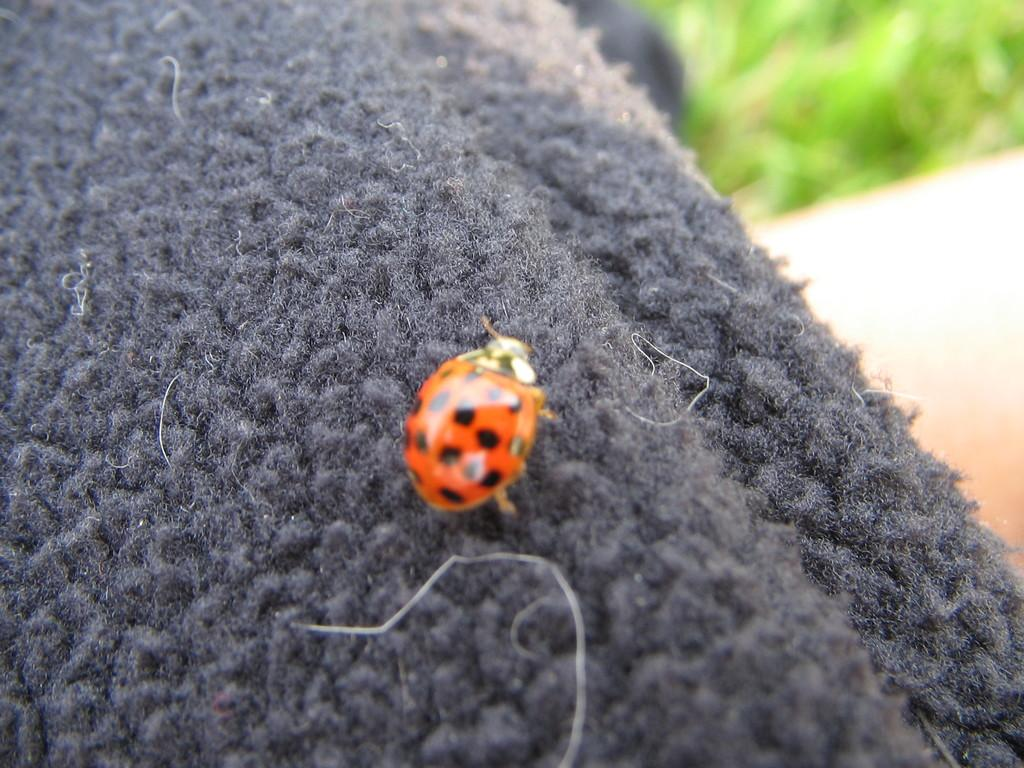What is on the woolen cloth in the image? There is a bug on the woolen cloth in the image. What can be seen on the backside of the woolen cloth? There is grass visible on the backside of the woolen cloth. What type of nerve can be seen in the image? There is no nerve present in the image; it features a bug on a woolen cloth and grass on the backside of the cloth. 